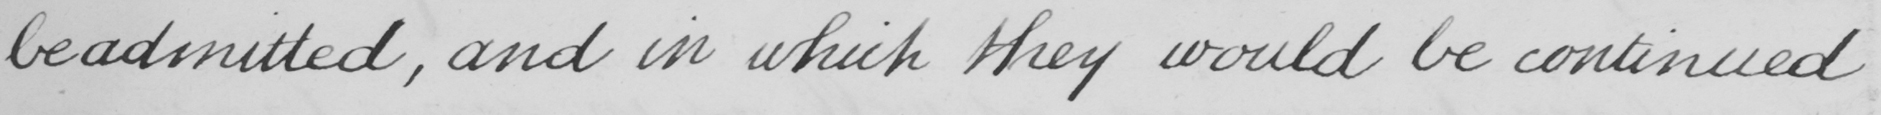Transcribe the text shown in this historical manuscript line. be admitted , and in which they would be continued 